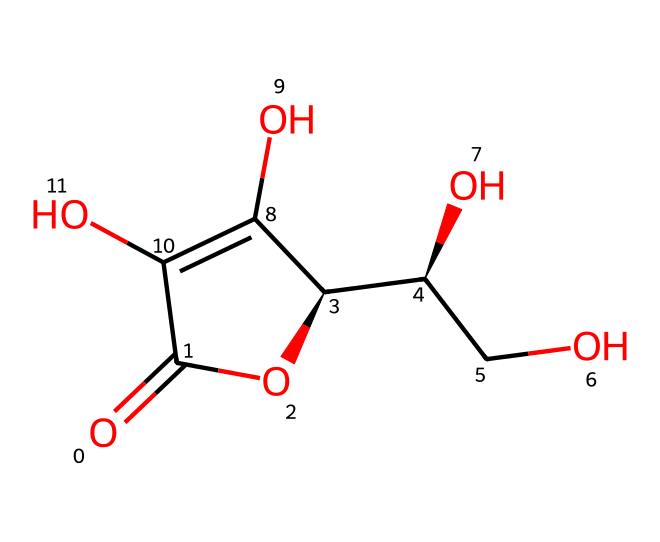How many carbon atoms are present in this molecule? To determine the number of carbon atoms, we count the carbon 'C' symbols in the molecular structure. Each carbon contributes one atom, thus visually identifying every carbon in the structure will yield the total count.
Answer: six What is the common name of this vitamin structure? This chemical structure corresponds to ascorbic acid commonly known as Vitamin C. It is recognized as an essential nutrient for humans.
Answer: Vitamin C How many hydroxyl (–OH) groups are in this molecule? The presence of hydroxyl groups can be identified by looking for 'O' atoms that are connected to hydrogen (–OH). Counting these groups in the structure will yield the total number. In this case, there are four hydroxyl groups.
Answer: four What type of chemical compound is this? This structure is classified as a vitamin or more specifically a vitamin with antioxidant properties, as it serves functions related to health and neutralization of free radicals.
Answer: vitamin Why does this vitamin have antioxidant properties? Vitamin C's antioxidant properties derive from its ability to donate electrons to free radicals. This reduces the reactive species, stabilizing them, thus preventing further cellular damage. The structure contains multiple hydroxyl groups, which facilitate this electron donation.
Answer: electron donation What is the molecular formula of this compound? To find the molecular formula, we sum up the quantities for each type of atom: there are C, H, and O atoms. The SMILES notation encodes how many of each kind are present, leading us to deduce the final count. The molecular formula comes out to be C6H8O6.
Answer: C6H8O6 